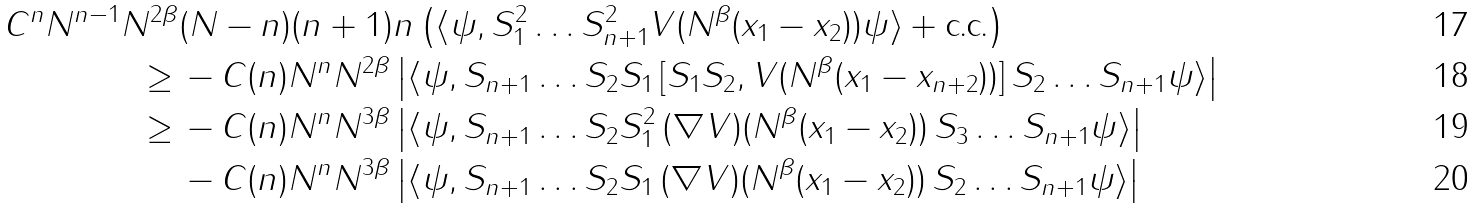<formula> <loc_0><loc_0><loc_500><loc_500>C ^ { n } N ^ { n - 1 } N ^ { 2 \beta } & ( N - n ) ( n + 1 ) n \left ( \langle \psi , S _ { 1 } ^ { 2 } \dots S _ { n + 1 } ^ { 2 } V ( N ^ { \beta } ( x _ { 1 } - x _ { 2 } ) ) \psi \rangle + \text {c.c.} \right ) \\ \geq \, & - C ( n ) N ^ { n } N ^ { 2 \beta } \left | \langle \psi , S _ { n + 1 } \dots S _ { 2 } S _ { 1 } \, [ S _ { 1 } S _ { 2 } , V ( N ^ { \beta } ( x _ { 1 } - x _ { n + 2 } ) ) ] \, S _ { 2 } \dots S _ { n + 1 } \psi \rangle \right | \\ \geq \, & - C ( n ) N ^ { n } N ^ { 3 \beta } \left | \langle \psi , S _ { n + 1 } \dots S _ { 2 } S ^ { 2 } _ { 1 } \, ( \nabla V ) ( N ^ { \beta } ( x _ { 1 } - x _ { 2 } ) ) \, S _ { 3 } \dots S _ { n + 1 } \psi \rangle \right | \\ & - C ( n ) N ^ { n } N ^ { 3 \beta } \left | \langle \psi , S _ { n + 1 } \dots S _ { 2 } S _ { 1 } \, ( \nabla V ) ( N ^ { \beta } ( x _ { 1 } - x _ { 2 } ) ) \, S _ { 2 } \dots S _ { n + 1 } \psi \rangle \right |</formula> 